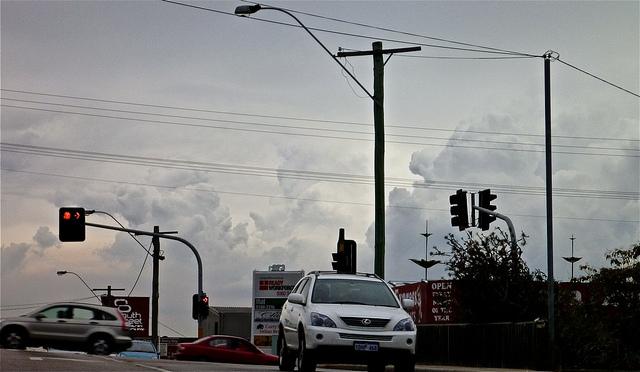How many vehicles are in the picture?
Be succinct. 3. Are the cars in motion?
Answer briefly. Yes. Which way can people turn?
Concise answer only. Right. Is there a street light close to the building?
Keep it brief. No. What is the man in?
Write a very short answer. Car. What vehicle is pictured?
Short answer required. Lexus. Does the white car have its headlights on?
Answer briefly. No. Is it sunny?
Be succinct. No. Which would cause the most damage in an accident: your car or this vehicle?
Keep it brief. This vehicle. What is on the windshield?
Quick response, please. Nothing. What is he riding?
Keep it brief. Car. How many lamp posts are in the picture?
Concise answer only. 1. What type of white vehicle is parked out front?
Keep it brief. Car. How many windows are on the front of the vehicle?
Be succinct. 1. What street is the car crossing?
Quick response, please. Main. What color is the street light?
Be succinct. Red. Is this a busy street?
Quick response, please. Yes. Is this a bus parking lot?
Short answer required. No. What color is the traffic light?
Answer briefly. Red. Are any of the vehicles in this scene driverless cars?
Short answer required. No. What vehicle is shown in the picture?
Quick response, please. Suv. 